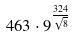Convert formula to latex. <formula><loc_0><loc_0><loc_500><loc_500>4 6 3 \cdot 9 ^ { \frac { 3 2 4 } { \sqrt { 8 } } }</formula> 